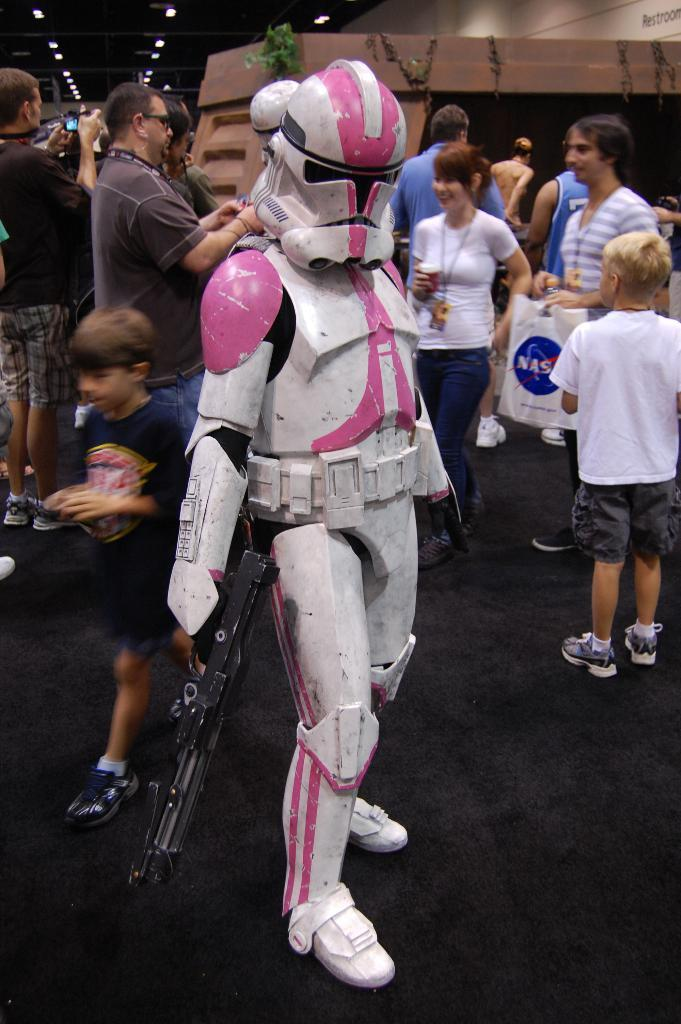What is the main subject of the image? There is a robot in the image. What is the robot holding? The robot is holding a gun. Where is the robot positioned in the image? The robot is standing on the floor. What else can be seen in the background of the image? There are people in the background of the image. What type of lighting is visible in the image? There are lights visible at the top of the image. What type of popcorn is being served in the image? There is no popcorn present in the image. How does the tramp interact with the robot in the image? There is no tramp present in the image, so it cannot interact with the robot. 